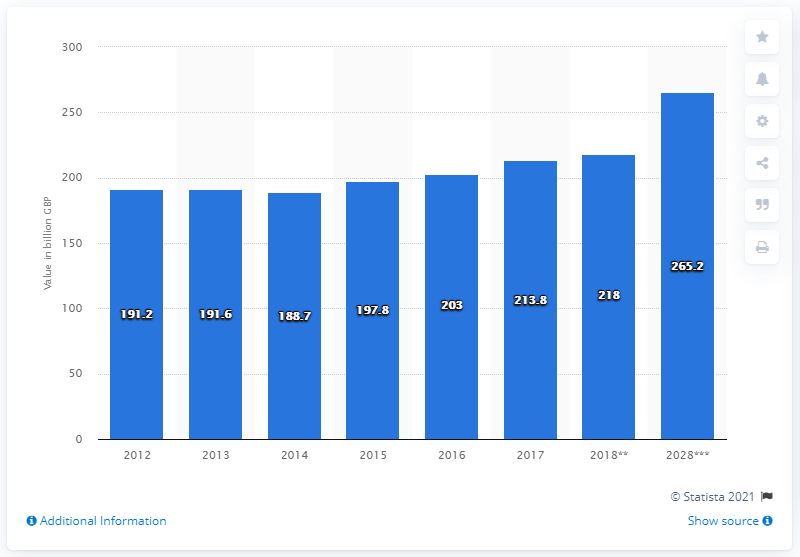Indicate a few pertinent items in this graphic. In 2017, the travel and tourism industry made a significant contribution to the UK's Gross Domestic Product (GDP) with a value of 213.8 billion pounds. 